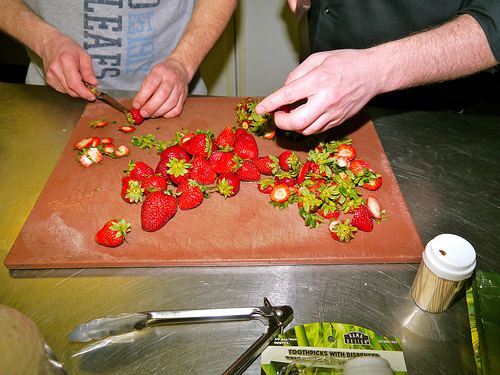<image>
Is there a strawberries on the table? No. The strawberries is not positioned on the table. They may be near each other, but the strawberries is not supported by or resting on top of the table. Where is the strawberry in relation to the table? Is it above the table? No. The strawberry is not positioned above the table. The vertical arrangement shows a different relationship. 